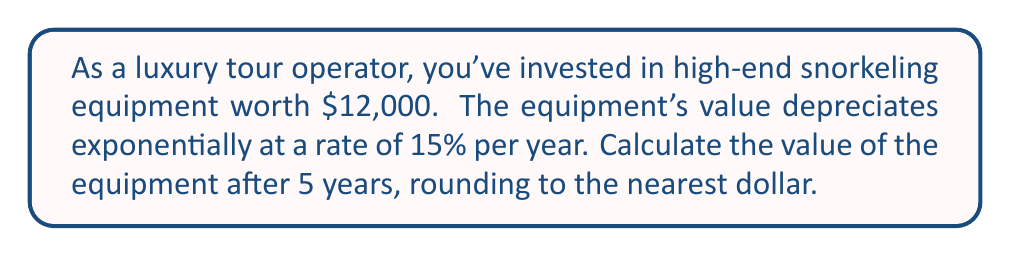Solve this math problem. To solve this problem, we'll use the exponential decay formula:

$$A = P(1-r)^t$$

Where:
$A$ = Final amount
$P$ = Initial principal balance
$r$ = Decay rate (as a decimal)
$t$ = Time in years

Given:
$P = 12000$
$r = 0.15$ (15% expressed as a decimal)
$t = 5$ years

Let's substitute these values into the formula:

$$A = 12000(1-0.15)^5$$

Simplify inside the parentheses:
$$A = 12000(0.85)^5$$

Calculate the exponent:
$$A = 12000 * 0.4437053$$

Multiply:
$$A = 5324.46$$

Rounding to the nearest dollar:
$$A ≈ 5324$$
Answer: $5,324 